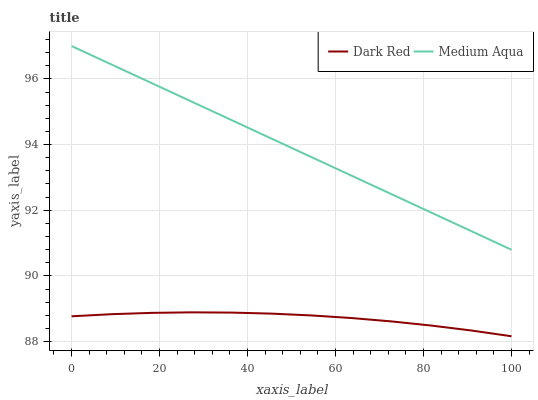Does Dark Red have the minimum area under the curve?
Answer yes or no. Yes. Does Medium Aqua have the maximum area under the curve?
Answer yes or no. Yes. Does Medium Aqua have the minimum area under the curve?
Answer yes or no. No. Is Medium Aqua the smoothest?
Answer yes or no. Yes. Is Dark Red the roughest?
Answer yes or no. Yes. Is Medium Aqua the roughest?
Answer yes or no. No. Does Medium Aqua have the lowest value?
Answer yes or no. No. Does Medium Aqua have the highest value?
Answer yes or no. Yes. Is Dark Red less than Medium Aqua?
Answer yes or no. Yes. Is Medium Aqua greater than Dark Red?
Answer yes or no. Yes. Does Dark Red intersect Medium Aqua?
Answer yes or no. No. 